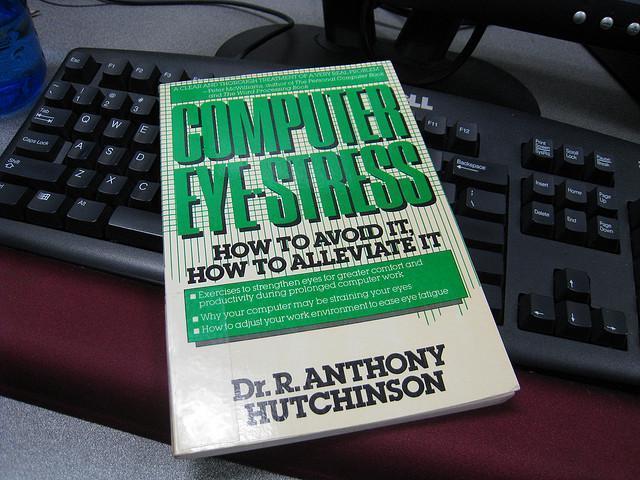How many cars are on the right of the horses and riders?
Give a very brief answer. 0. 